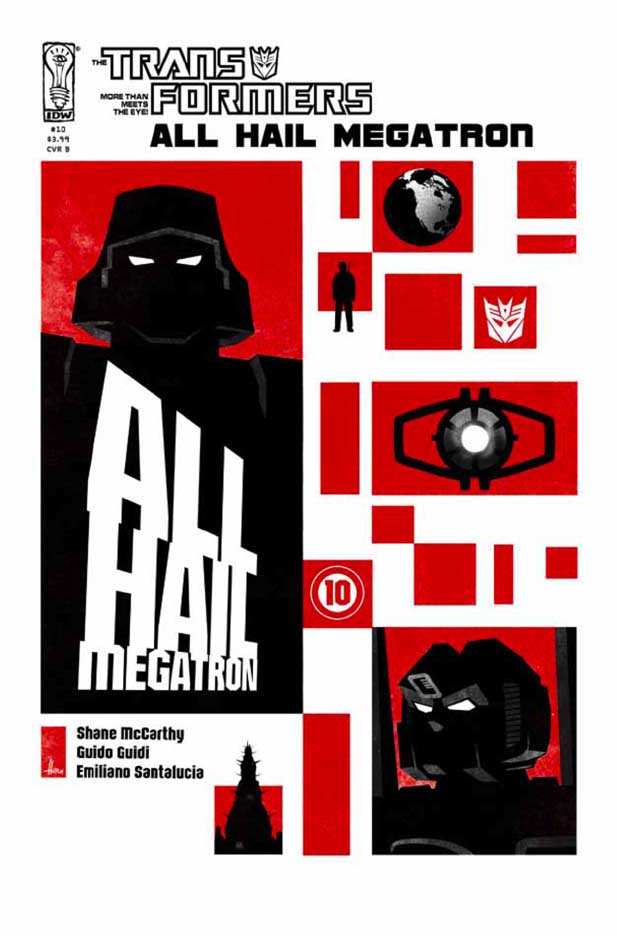Imagine the red and black colors are replaced with green and blue. How would this change the perception of the cover? Replacing the red and black with green and blue would significantly alter the perception of the cover. Green typically signifies growth, vitality, and in some contexts, tranquility, while blue is often associated with calm, stability, and intellect. This new color scheme could shift the tone from aggressive and dangerous to one that feels more hopeful or strategic. Such colors might suggest themes of renewal or a tactical approach rather than brute force. The overall impact would likely evoke a less menacing and more optimistic or contemplative narrative, contrasting sharply with the original intense and perilous tone. 